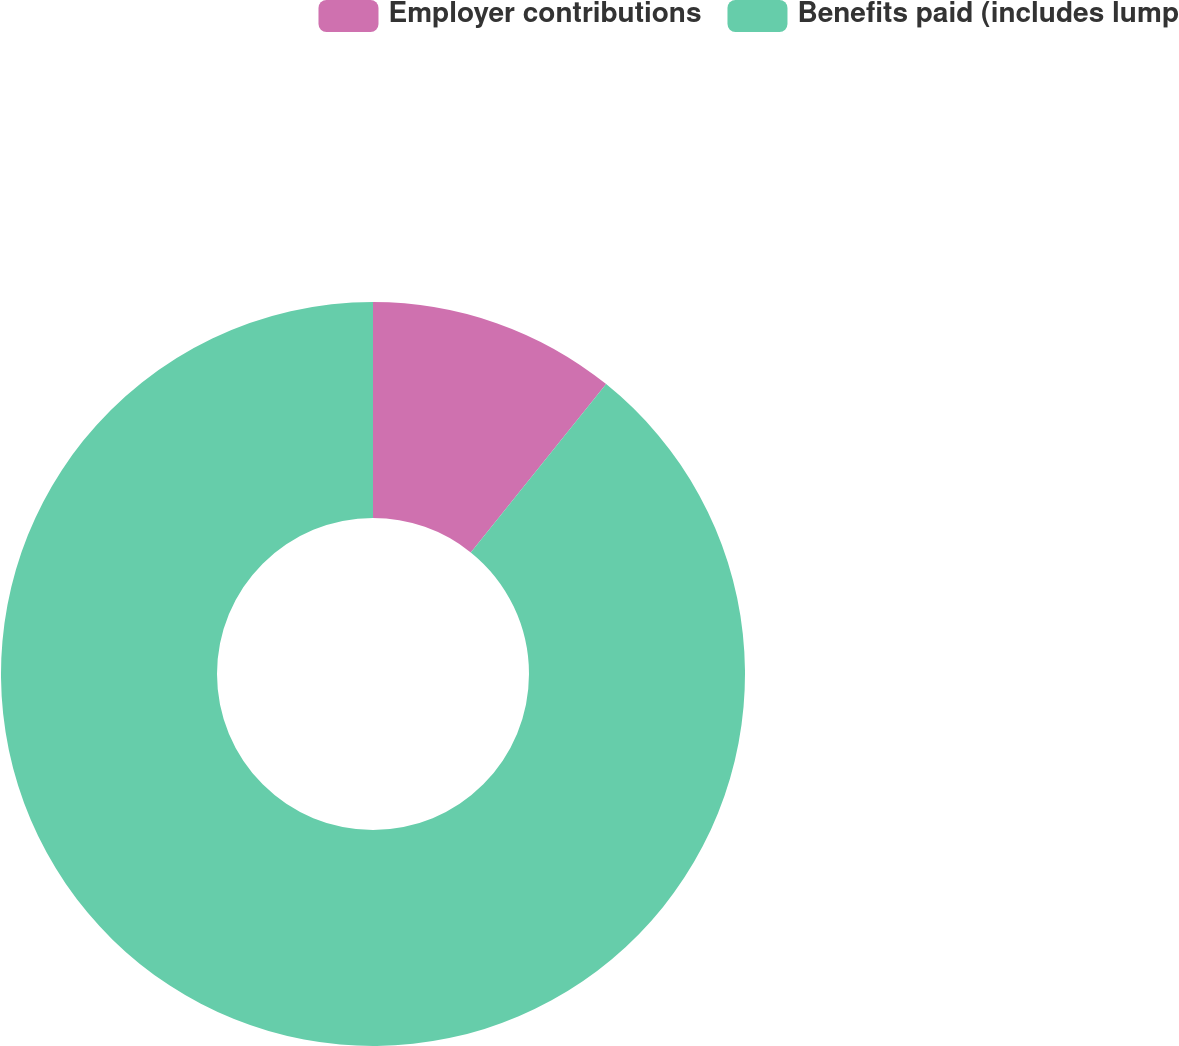Convert chart to OTSL. <chart><loc_0><loc_0><loc_500><loc_500><pie_chart><fcel>Employer contributions<fcel>Benefits paid (includes lump<nl><fcel>10.78%<fcel>89.22%<nl></chart> 